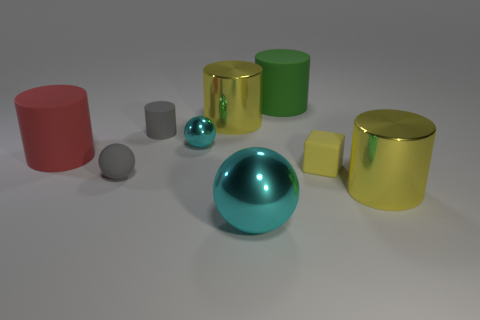The large red matte thing is what shape?
Make the answer very short. Cylinder. The big yellow thing that is right of the large yellow thing that is behind the gray rubber cylinder is what shape?
Provide a succinct answer. Cylinder. What number of other objects are the same shape as the tiny yellow thing?
Provide a succinct answer. 0. There is a gray matte cylinder on the left side of the large metallic cylinder left of the tiny yellow thing; what is its size?
Your answer should be compact. Small. Are there any small blue shiny balls?
Give a very brief answer. No. There is a gray matte object to the right of the gray rubber sphere; what number of large red rubber things are in front of it?
Your answer should be compact. 1. What is the shape of the small gray rubber thing that is in front of the small yellow object?
Keep it short and to the point. Sphere. There is a yellow cylinder that is right of the big rubber cylinder that is right of the big cyan thing that is in front of the tiny cyan metallic object; what is its material?
Provide a short and direct response. Metal. How many other things are the same size as the red object?
Your response must be concise. 4. There is a small cyan object that is the same shape as the large cyan thing; what is its material?
Give a very brief answer. Metal. 